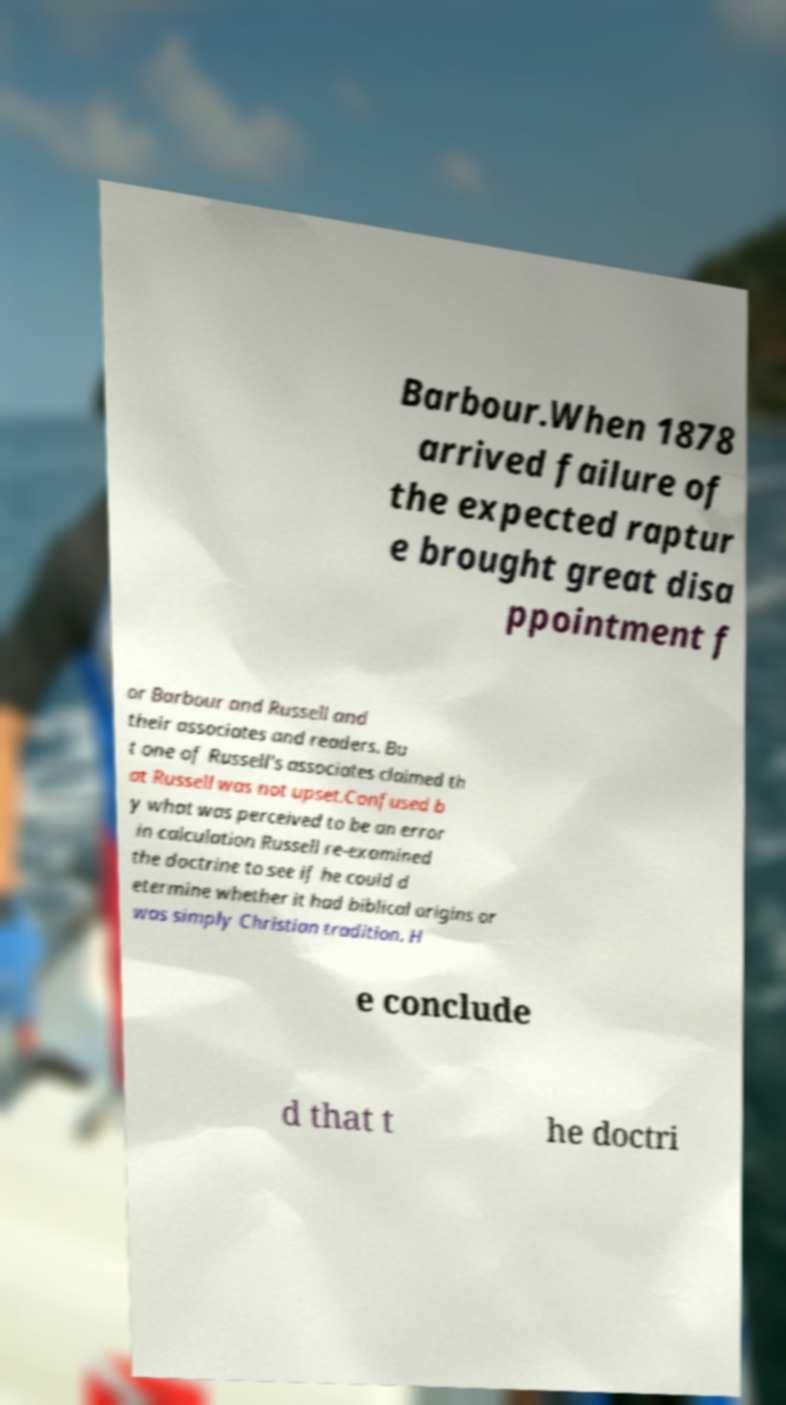For documentation purposes, I need the text within this image transcribed. Could you provide that? Barbour.When 1878 arrived failure of the expected raptur e brought great disa ppointment f or Barbour and Russell and their associates and readers. Bu t one of Russell's associates claimed th at Russell was not upset.Confused b y what was perceived to be an error in calculation Russell re-examined the doctrine to see if he could d etermine whether it had biblical origins or was simply Christian tradition. H e conclude d that t he doctri 